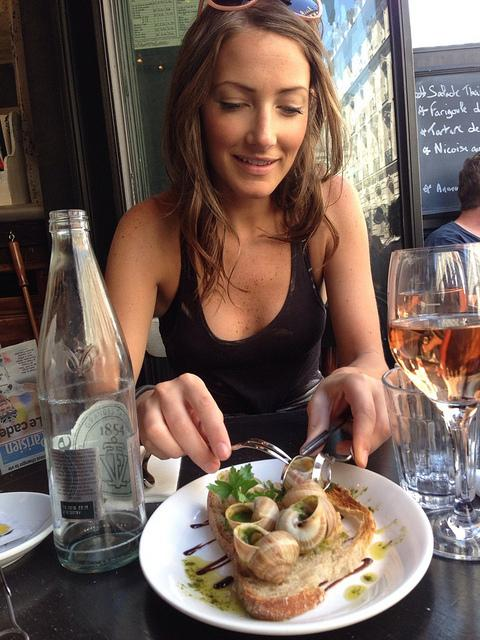What country are they in? Please explain your reasoning. france. She is eating escargot which is a dish they serve there 